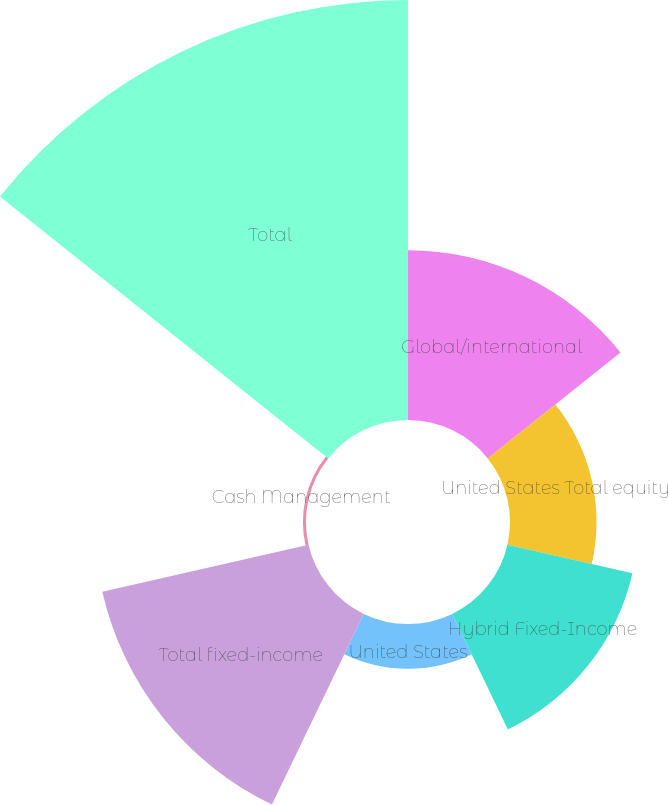Convert chart. <chart><loc_0><loc_0><loc_500><loc_500><pie_chart><fcel>Global/international<fcel>United States Total equity<fcel>Hybrid Fixed-Income<fcel>United States<fcel>Total fixed-income<fcel>Cash Management<fcel>Total<nl><fcel>15.96%<fcel>8.13%<fcel>12.05%<fcel>4.21%<fcel>19.88%<fcel>0.29%<fcel>39.47%<nl></chart> 